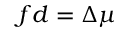Convert formula to latex. <formula><loc_0><loc_0><loc_500><loc_500>f d = \Delta \mu</formula> 